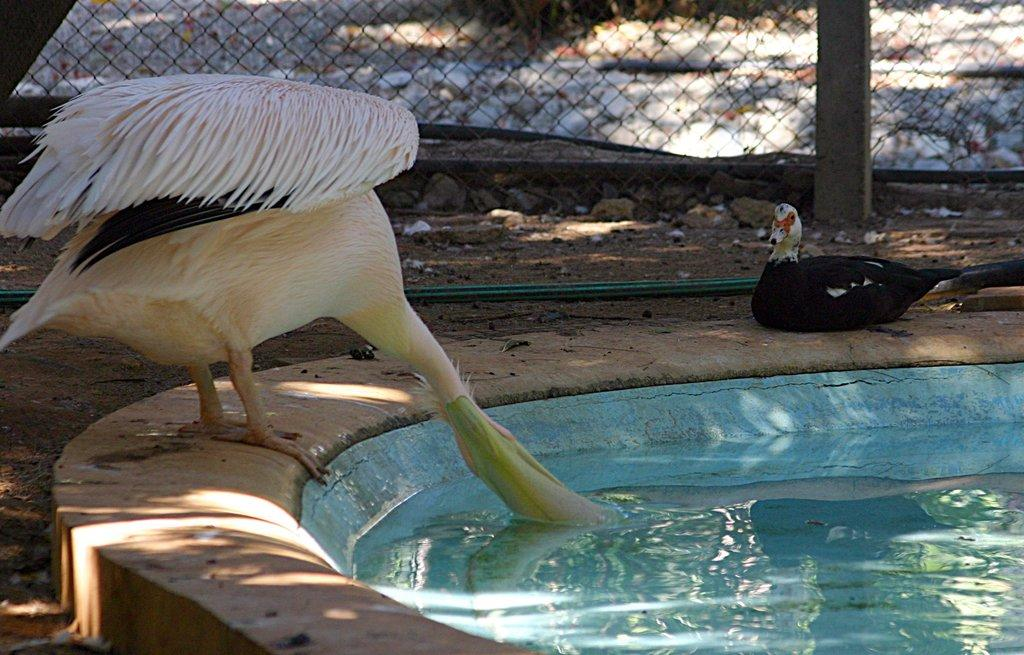What animal is in the foreground of the image? There is a duck in the foreground of the image. What is the duck doing in the image? The duck is drinking water. Can you describe the color of the duck? There is a black color duck in the image. What else can be seen in the image besides the duck? There is a pipe, the ground, and fencing visible in the image. What type of jeans is the snake wearing in the image? There is no snake or jeans present in the image. Where is the middle of the image located? The concept of a "middle" of the image is not applicable in this context, as it is a two-dimensional representation. 